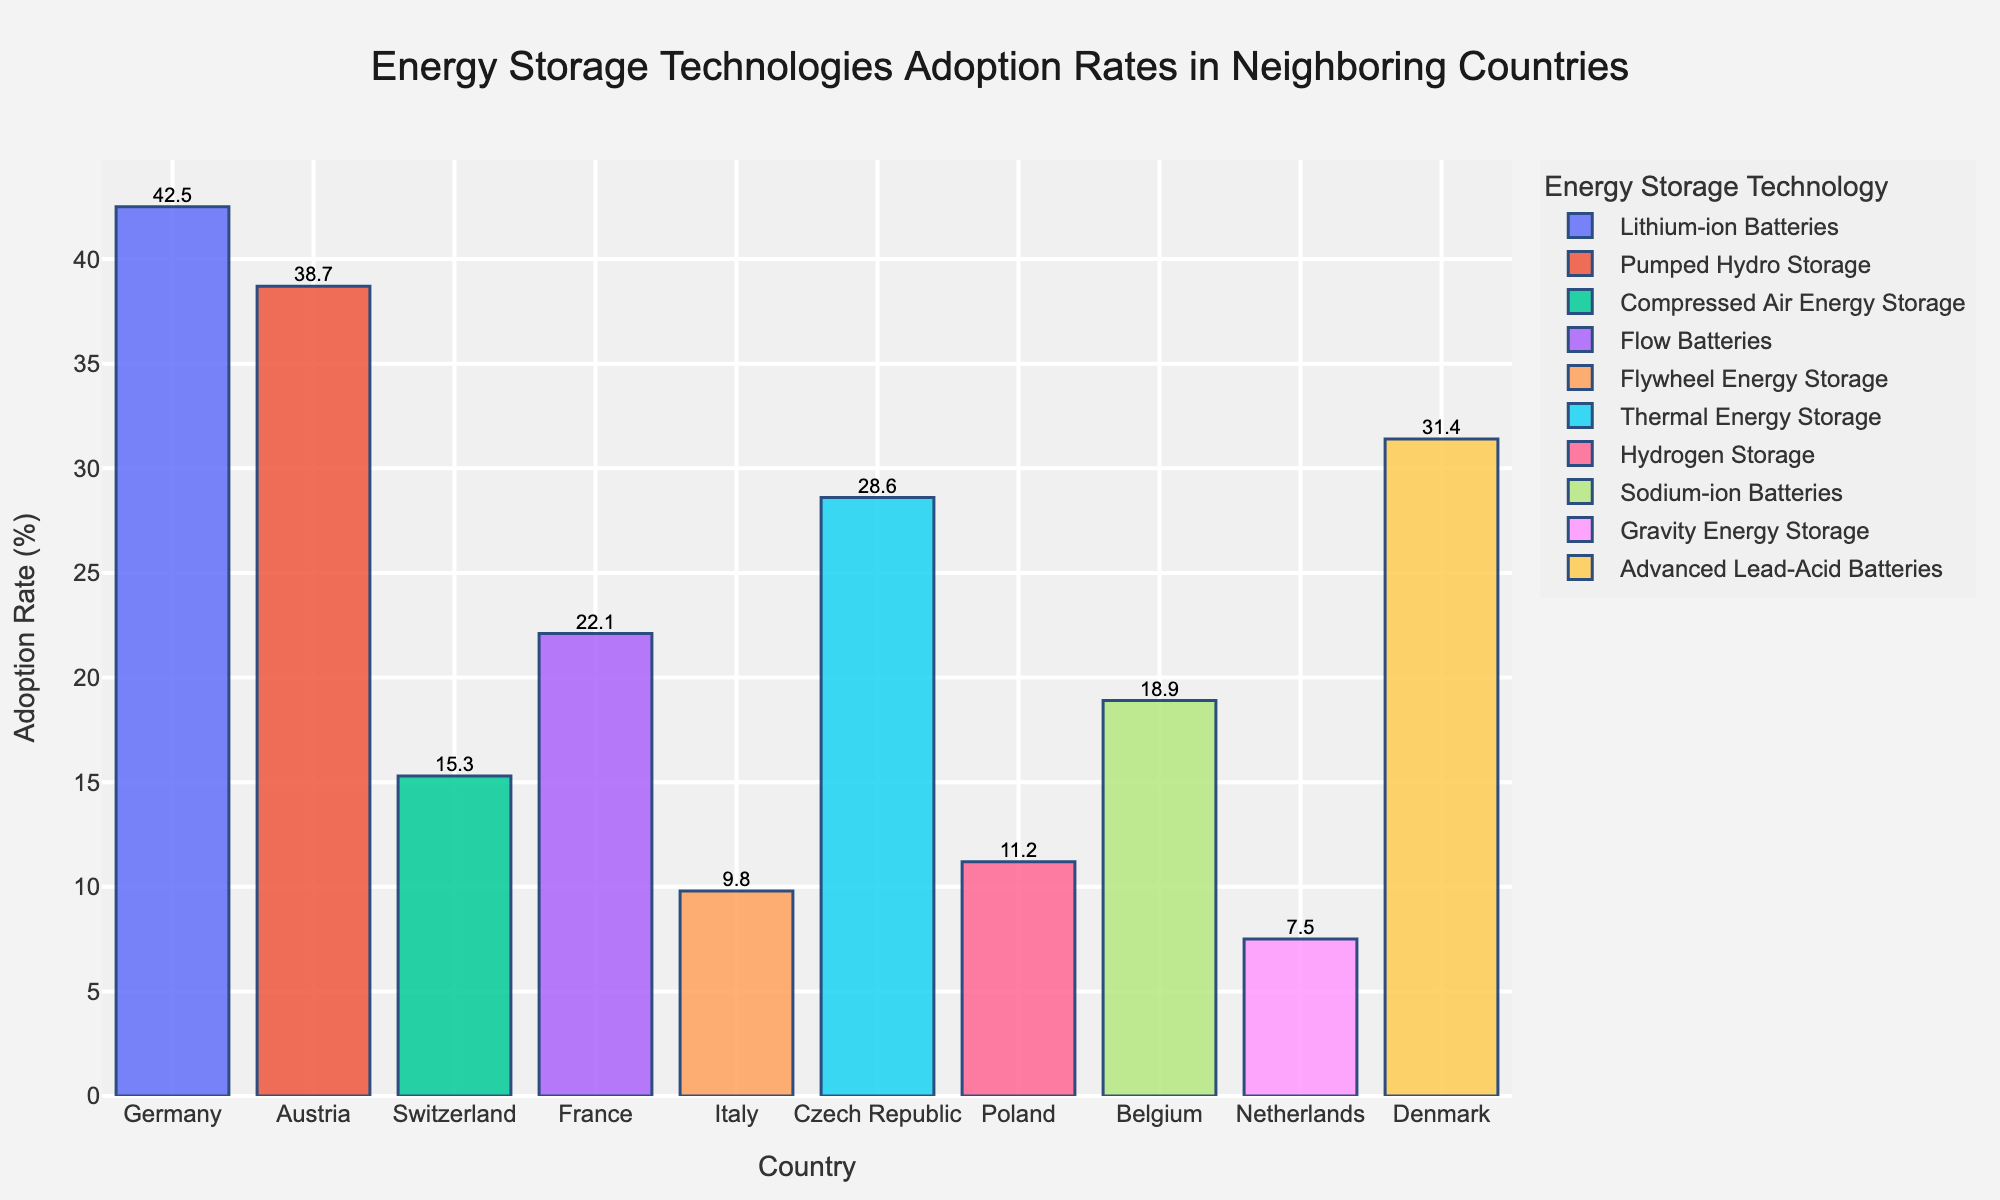What's the most commonly adopted energy storage technology among the neighboring countries? By examining the heights of the bars, we observe that Germany's "Lithium-ion Batteries" has the highest adoption rate of 42.5%, making it the most commonly adopted technology.
Answer: Lithium-ion Batteries Which country has the lowest adoption rate of any energy storage technology? The shortest bar in the chart corresponds to the Netherlands with "Gravity Energy Storage" at an adoption rate of 7.5%.
Answer: Netherlands How does the adoption rate of Flow Batteries in France compare to the adoption rate of Thermal Energy Storage in the Czech Republic? The bar representing Flow Batteries in France has an adoption rate of 22.1%, whereas the bar for Thermal Energy Storage in the Czech Republic shows an adoption rate of 28.6%. Hence, the Czech Republic has a higher adoption rate.
Answer: France's adoption rate is lower What is the difference in adoption rates between the highest (Lithium-ion Batteries in Germany) and the lowest (Gravity Energy Storage in Netherlands)? Lithium-ion Batteries in Germany have an adoption rate of 42.5%, and Gravity Energy Storage in the Netherlands has an adoption rate of 7.5%. The difference is calculated as 42.5 - 7.5.
Answer: 35 Calculate the average adoption rate of all technologies in the chart. Sum all adoption rates: 42.5 + 38.7 + 15.3 + 22.1 + 9.8 + 28.6 + 11.2 + 18.9 + 7.5 + 31.4 = 226.0. Divide by the number of countries: 226.0 / 10.
Answer: 22.6 How many countries have an adoption rate higher than 30%? By examining the bars, we identify that Germany with 42.5%, Austria with 38.7%, and Denmark with 31.4% have adoption rates higher than 30%. This totals to three countries.
Answer: 3 What is the combined adoption rate of advanced battery technologies like Lithium-ion, Flow, Sodium-ion, and Advanced Lead-Acid Batteries? Sum the adoption rates of these technologies: Lithium-ion Batteries in Germany (42.5), Flow Batteries in France (22.1), Sodium-ion Batteries in Belgium (18.9), Advanced Lead-Acid Batteries in Denmark (31.4). The calculation is 42.5 + 22.1 + 18.9 + 31.4.
Answer: 114.9 